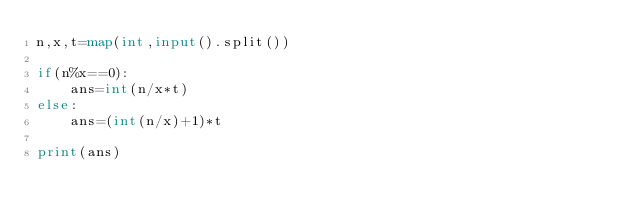Convert code to text. <code><loc_0><loc_0><loc_500><loc_500><_Python_>n,x,t=map(int,input().split())

if(n%x==0):
    ans=int(n/x*t)
else:
    ans=(int(n/x)+1)*t

print(ans)</code> 